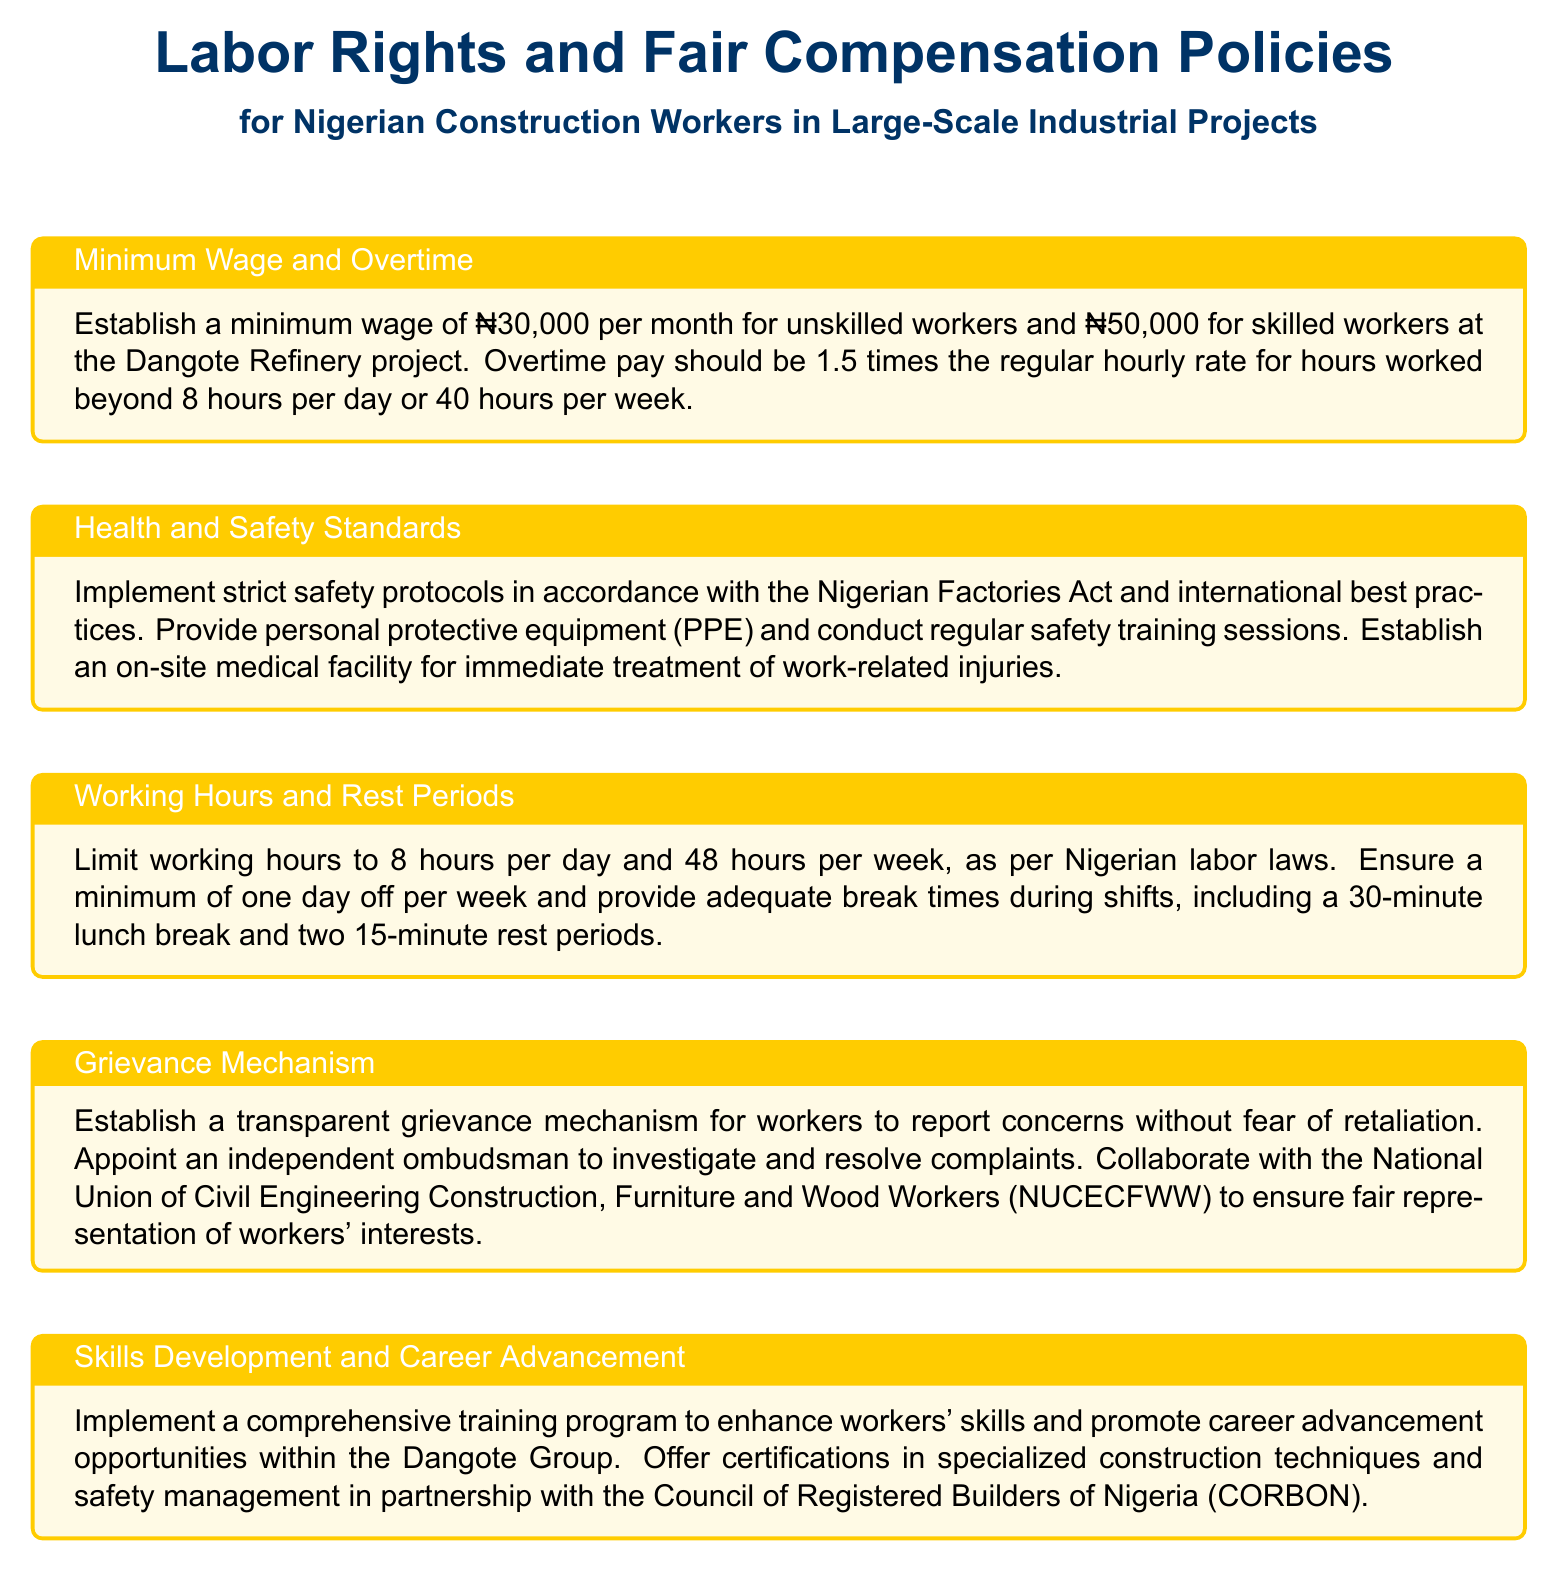What is the minimum wage for unskilled workers? The document states that the minimum wage for unskilled workers at the Dangote Refinery project is ₦30,000 per month.
Answer: ₦30,000 What should be the overtime pay rate? According to the document, overtime pay should be 1.5 times the regular hourly rate for hours worked beyond 8 hours per day or 40 hours per week.
Answer: 1.5 times the regular hourly rate What is the maximum number of working hours per week? The document specifies that working hours should be limited to 48 hours per week as per Nigerian labor laws.
Answer: 48 hours What is the purpose of the grievance mechanism? The grievance mechanism is designed to allow workers to report concerns without fear of retaliation.
Answer: To report concerns without fear of retaliation Who will conduct the safety training sessions? The document indicates that safety training sessions will be conducted regularly to ensure compliance with safety protocols.
Answer: Regularly What is the minimum number of days off required per week? The policy document states that workers are entitled to a minimum of one day off per week.
Answer: One day off Which organization collaborates with the project for workers' representation? The document mentions collaboration with the National Union of Civil Engineering Construction, Furniture and Wood Workers (NUCECFWW) to ensure fair representation of workers' interests.
Answer: NUCECFWW What is a key component of the skills development program? The comprehensive training program mentioned in the document aims to enhance workers' skills and promote career advancement opportunities within the Dangote Group.
Answer: Enhance workers' skills What should be provided regarding health and safety? The document states that personal protective equipment (PPE) should be provided in accordance with safety standards.
Answer: Personal protective equipment (PPE) 